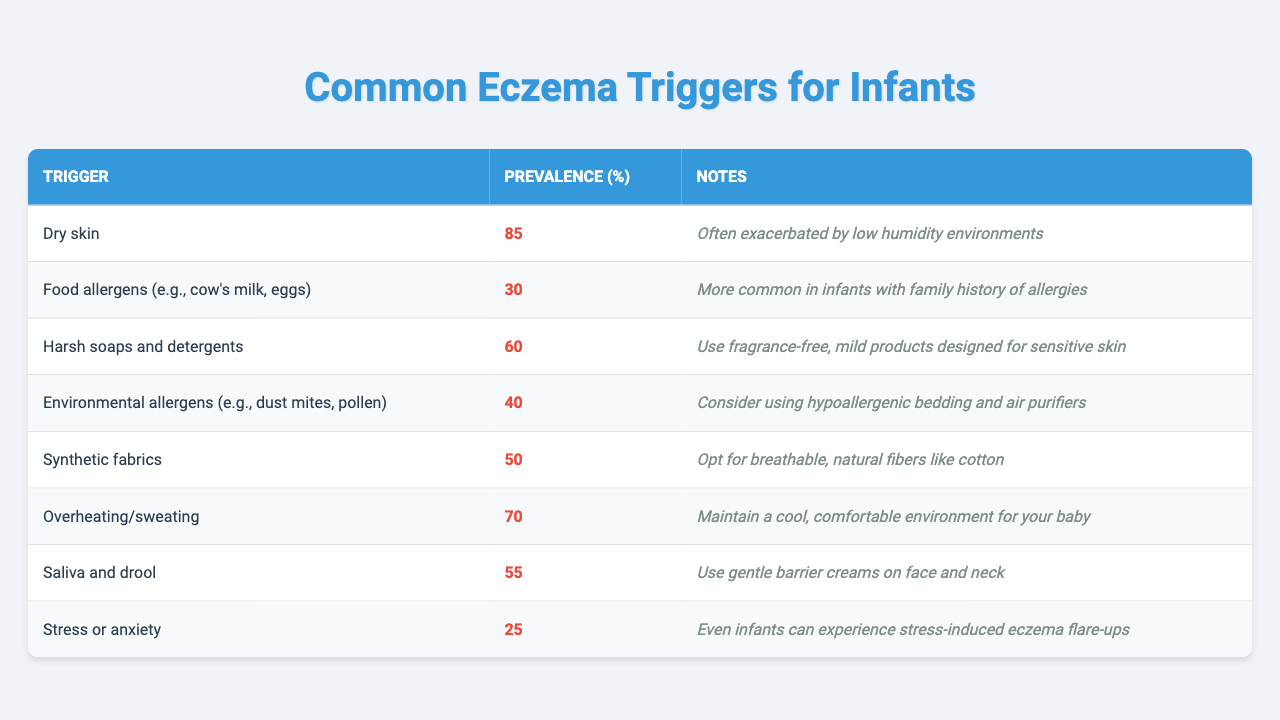What is the most common eczema trigger for infants? The table indicates that "Dry skin" has the highest prevalence at 85%.
Answer: 85% Which trigger has the lowest prevalence? According to the table, "Stress or anxiety" has the lowest prevalence at 25%.
Answer: 25% What percentage of infants are affected by harsh soaps and detergents? The prevalence of "Harsh soaps and detergents" is listed as 60%.
Answer: 60% How many triggers have a prevalence of 50% or higher? The table shows 5 triggers with prevalence percentages of 50% or more: Dry skin (85%), Overheating/sweating (70%), Harsh soaps and detergents (60%), Saliva and drool (55%), and Synthetic fabrics (50%).
Answer: 5 What is the combined prevalence of environmental allergens and food allergens? The prevalence for environmental allergens is 40% and for food allergens is 30%. Adding these gives 40% + 30% = 70%.
Answer: 70% Are food allergens more common than stress or anxiety as eczema triggers? Yes, food allergens have a prevalence of 30%, while stress or anxiety has a prevalence of 25%. Thus, food allergens are more common.
Answer: Yes If an infant has dry skin and is exposed to synthetic fabrics, what is the likelihood of developing eczema from these triggers? The likelihood is based on the individual prevalences: Dry skin has 85% and synthetic fabrics have 50%. However, the actual risk of developing eczema would depend on whether these triggers interact or are considered separately.
Answer: 85% and 50% Which two triggers when combined have the highest total prevalence in the baby? The top two triggers, Dry skin (85%) and Overheating/sweating (70%), when combined have a total prevalence of 155%.
Answer: 155% What steps should be taken if a baby has a high prevalence trigger like dry skin? To address a high prevalence trigger like dry skin, it's important to maintain humidity levels and possibly apply suitable moisturizing products.
Answer: Use moisturizers and maintain humidity 